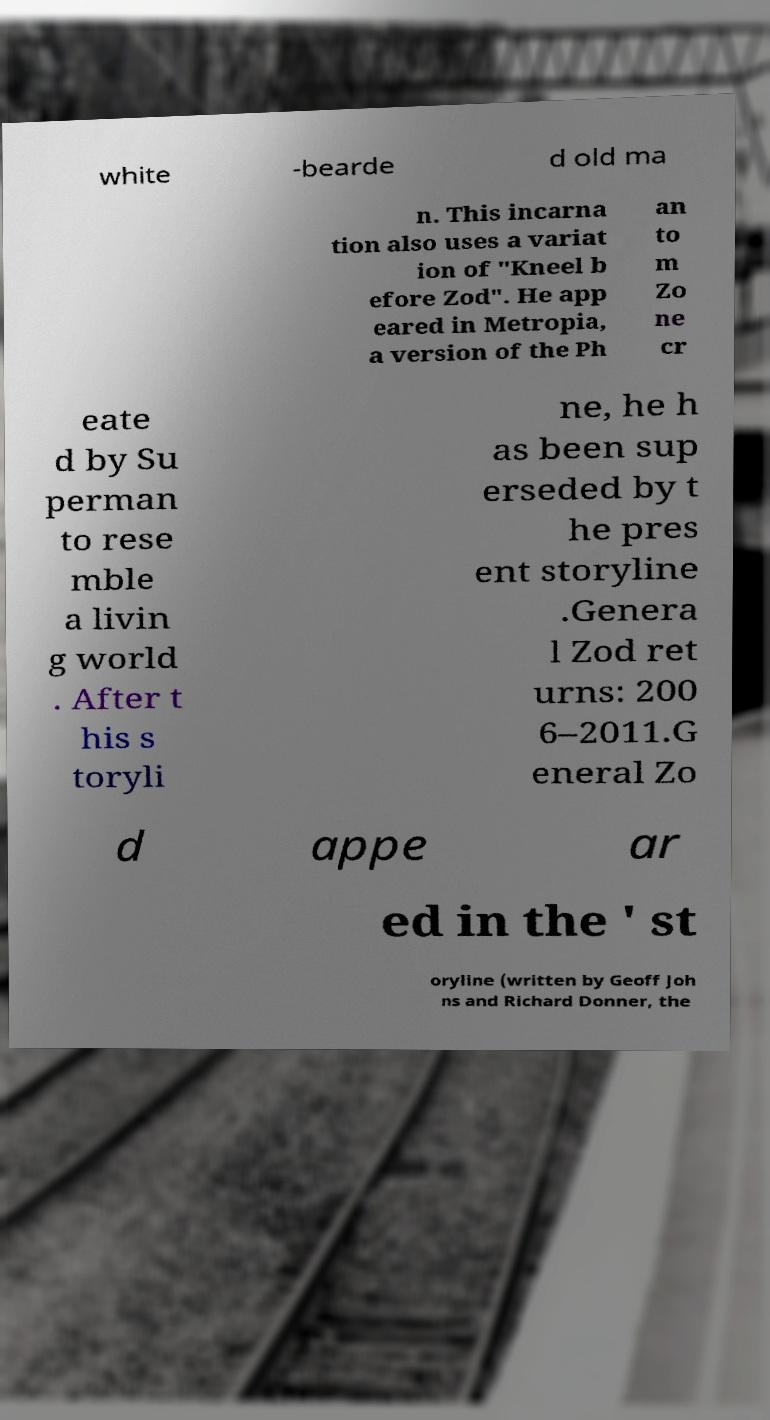Could you assist in decoding the text presented in this image and type it out clearly? white -bearde d old ma n. This incarna tion also uses a variat ion of "Kneel b efore Zod". He app eared in Metropia, a version of the Ph an to m Zo ne cr eate d by Su perman to rese mble a livin g world . After t his s toryli ne, he h as been sup erseded by t he pres ent storyline .Genera l Zod ret urns: 200 6–2011.G eneral Zo d appe ar ed in the ' st oryline (written by Geoff Joh ns and Richard Donner, the 